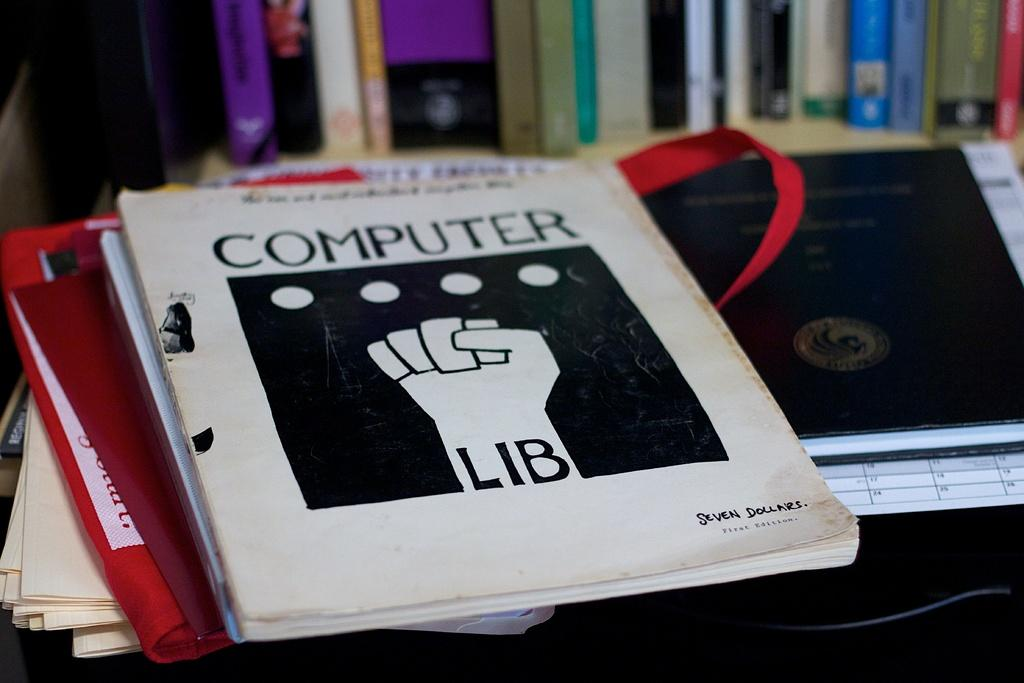<image>
Create a compact narrative representing the image presented. A book titled Computer Lib for seven dollars 